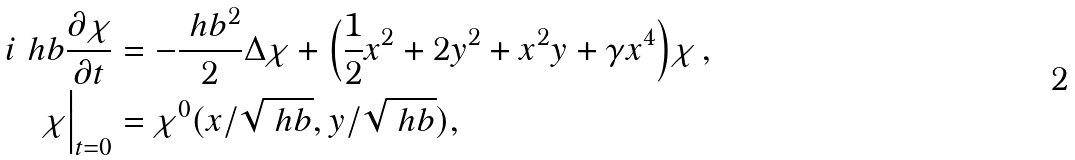<formula> <loc_0><loc_0><loc_500><loc_500>i \ h b \frac { \partial \chi } { \partial t } & = - \frac { \ h b ^ { 2 } } { 2 } \Delta \chi + \Big ( \frac { 1 } { 2 } x ^ { 2 } + 2 y ^ { 2 } + x ^ { 2 } y + \gamma x ^ { 4 } \Big ) \chi \, , \\ \chi \Big | _ { t = 0 } & = \chi ^ { 0 } ( { x } / { \sqrt { \ h b } } , { y } / { \sqrt { \ h b } } ) ,</formula> 